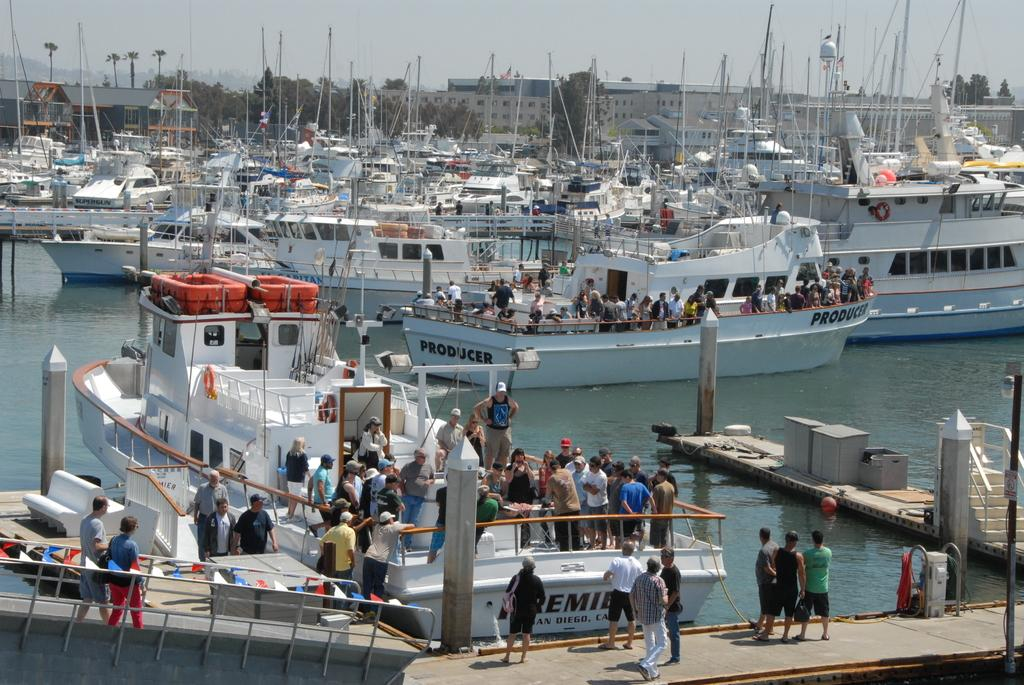What type of vehicles can be seen in the image? There are boats in the image. What else is present in the image besides the boats? There are people, water, trees, buildings, and the sky visible in the image. Can you describe the setting of the image? The image features a water body with boats, surrounded by trees, buildings, and people. The sky is also visible at the top of the image. What type of vase is being used in the battle depicted in the image? There is no vase or battle present in the image. What flavor of pie is being served to the people in the image? There is no pie present in the image. 